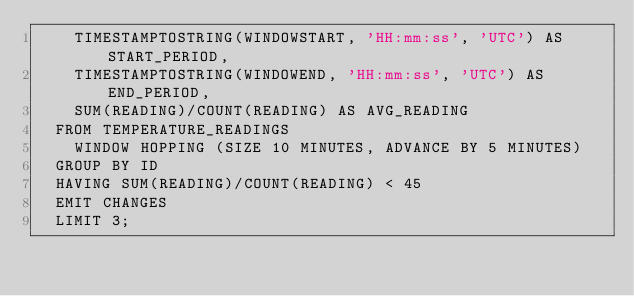Convert code to text. <code><loc_0><loc_0><loc_500><loc_500><_SQL_>    TIMESTAMPTOSTRING(WINDOWSTART, 'HH:mm:ss', 'UTC') AS START_PERIOD,
    TIMESTAMPTOSTRING(WINDOWEND, 'HH:mm:ss', 'UTC') AS END_PERIOD,
    SUM(READING)/COUNT(READING) AS AVG_READING
  FROM TEMPERATURE_READINGS
    WINDOW HOPPING (SIZE 10 MINUTES, ADVANCE BY 5 MINUTES)
  GROUP BY ID
  HAVING SUM(READING)/COUNT(READING) < 45
  EMIT CHANGES
  LIMIT 3;
</code> 